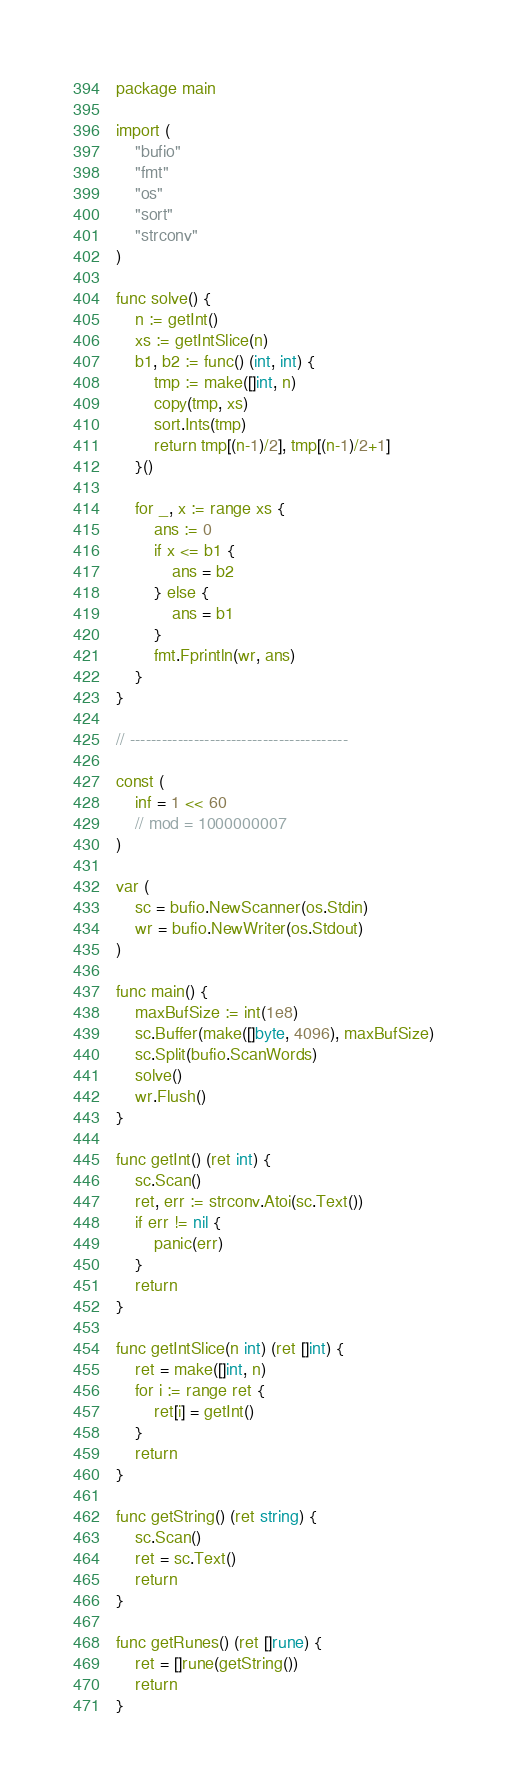Convert code to text. <code><loc_0><loc_0><loc_500><loc_500><_Go_>package main

import (
	"bufio"
	"fmt"
	"os"
	"sort"
	"strconv"
)

func solve() {
	n := getInt()
	xs := getIntSlice(n)
	b1, b2 := func() (int, int) {
		tmp := make([]int, n)
		copy(tmp, xs)
		sort.Ints(tmp)
		return tmp[(n-1)/2], tmp[(n-1)/2+1]
	}()

	for _, x := range xs {
		ans := 0
		if x <= b1 {
			ans = b2
		} else {
			ans = b1
		}
		fmt.Fprintln(wr, ans)
	}
}

// -----------------------------------------

const (
	inf = 1 << 60
	// mod = 1000000007
)

var (
	sc = bufio.NewScanner(os.Stdin)
	wr = bufio.NewWriter(os.Stdout)
)

func main() {
	maxBufSize := int(1e8)
	sc.Buffer(make([]byte, 4096), maxBufSize)
	sc.Split(bufio.ScanWords)
	solve()
	wr.Flush()
}

func getInt() (ret int) {
	sc.Scan()
	ret, err := strconv.Atoi(sc.Text())
	if err != nil {
		panic(err)
	}
	return
}

func getIntSlice(n int) (ret []int) {
	ret = make([]int, n)
	for i := range ret {
		ret[i] = getInt()
	}
	return
}

func getString() (ret string) {
	sc.Scan()
	ret = sc.Text()
	return
}

func getRunes() (ret []rune) {
	ret = []rune(getString())
	return
}
</code> 